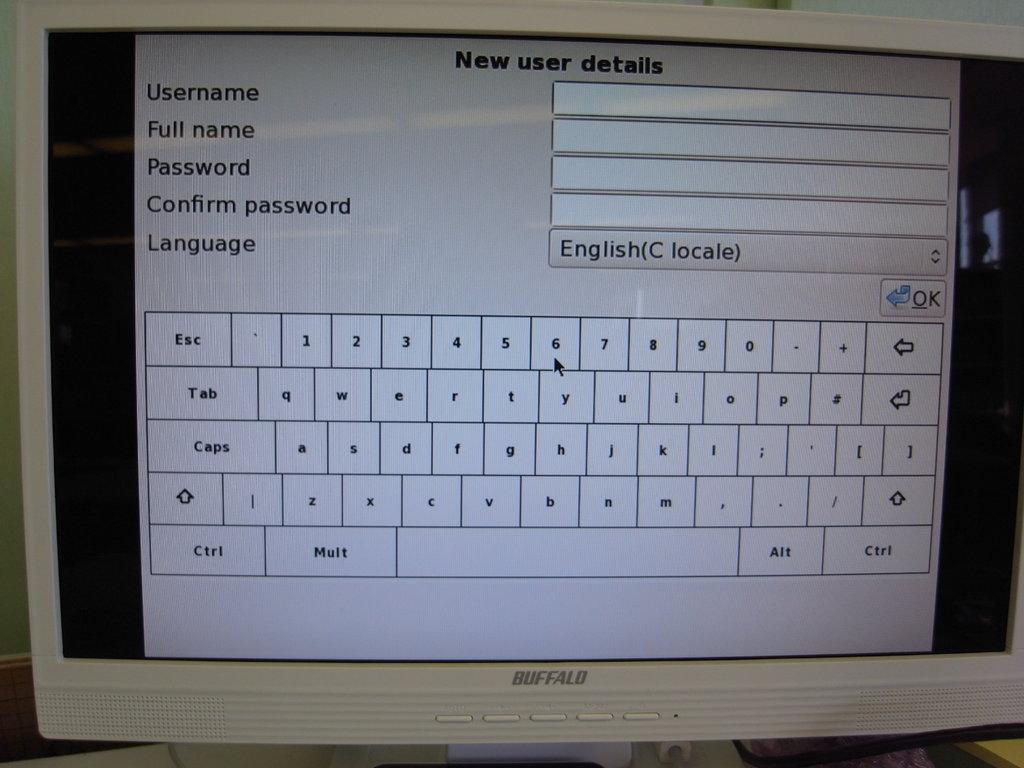What does the screen say to confirm?
Provide a short and direct response. Password. What is this form called?
Provide a short and direct response. New user details. 